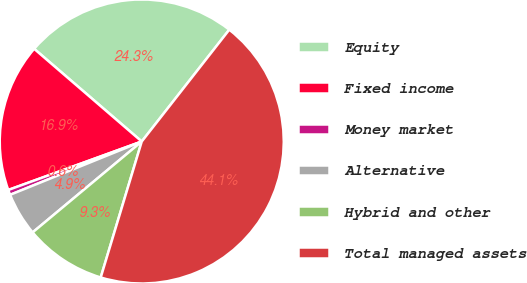<chart> <loc_0><loc_0><loc_500><loc_500><pie_chart><fcel>Equity<fcel>Fixed income<fcel>Money market<fcel>Alternative<fcel>Hybrid and other<fcel>Total managed assets<nl><fcel>24.25%<fcel>16.86%<fcel>0.58%<fcel>4.93%<fcel>9.28%<fcel>44.09%<nl></chart> 